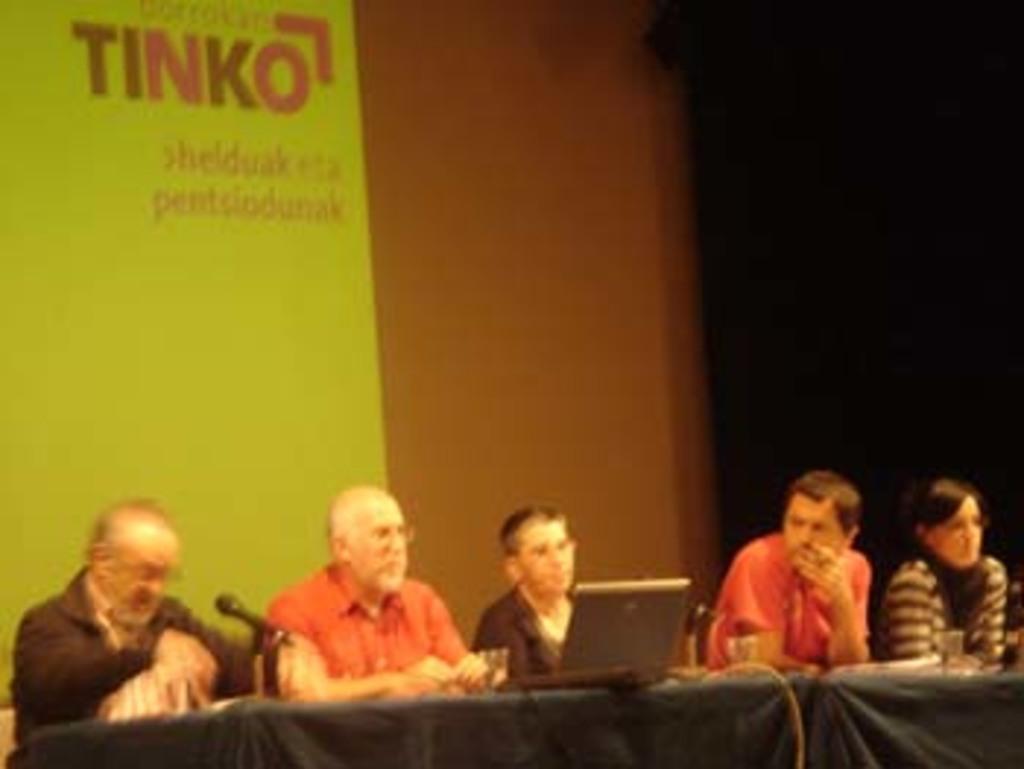In one or two sentences, can you explain what this image depicts? In the image there are few persons sitting in front of table with mic and laptop on it and behind them there is a banner, this seems to be clicked on a stage. 